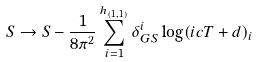<formula> <loc_0><loc_0><loc_500><loc_500>S \rightarrow S - \frac { 1 } { 8 \pi ^ { 2 } } \sum _ { i = 1 } ^ { h _ { ( 1 , 1 ) } } \delta ^ { i } _ { G S } \log ( i c T + d ) _ { i }</formula> 